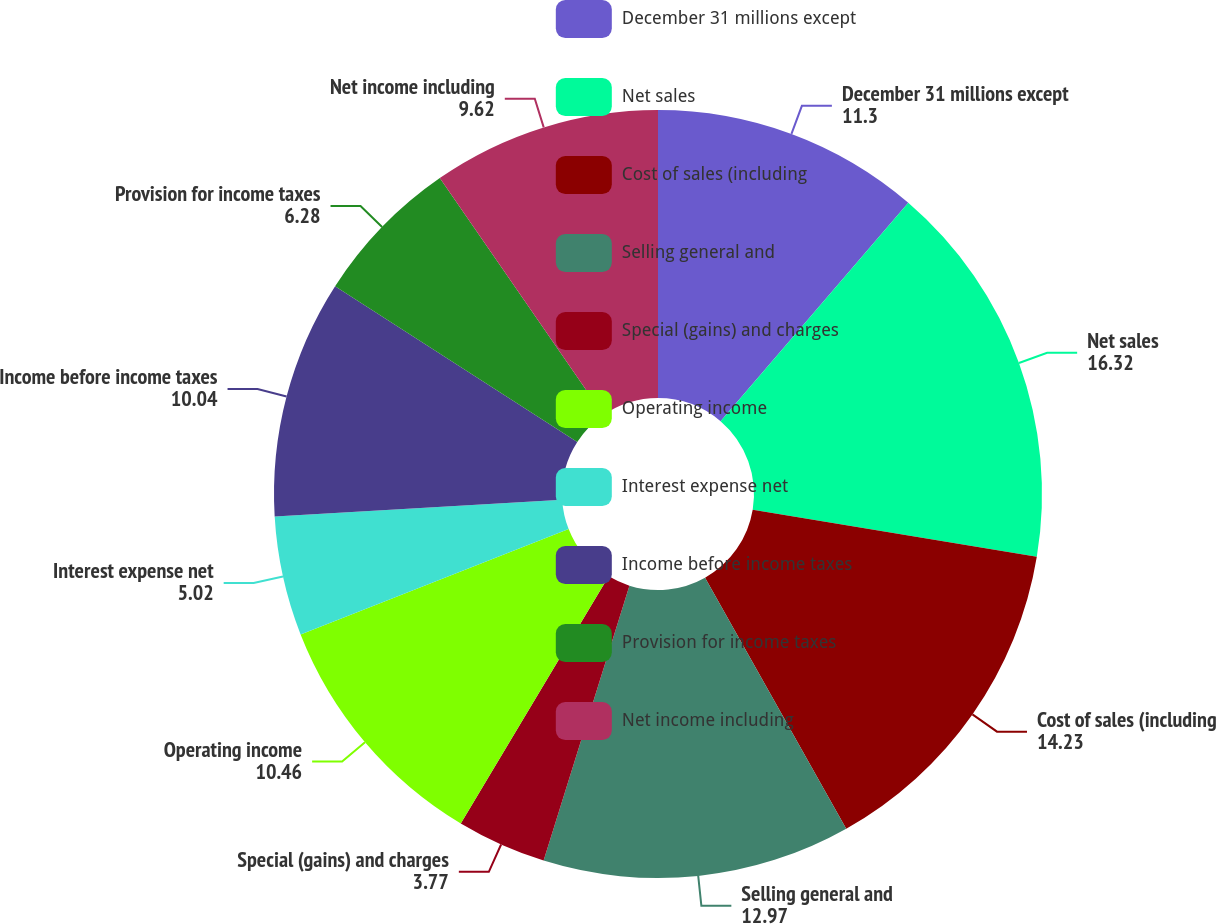Convert chart. <chart><loc_0><loc_0><loc_500><loc_500><pie_chart><fcel>December 31 millions except<fcel>Net sales<fcel>Cost of sales (including<fcel>Selling general and<fcel>Special (gains) and charges<fcel>Operating income<fcel>Interest expense net<fcel>Income before income taxes<fcel>Provision for income taxes<fcel>Net income including<nl><fcel>11.3%<fcel>16.32%<fcel>14.23%<fcel>12.97%<fcel>3.77%<fcel>10.46%<fcel>5.02%<fcel>10.04%<fcel>6.28%<fcel>9.62%<nl></chart> 